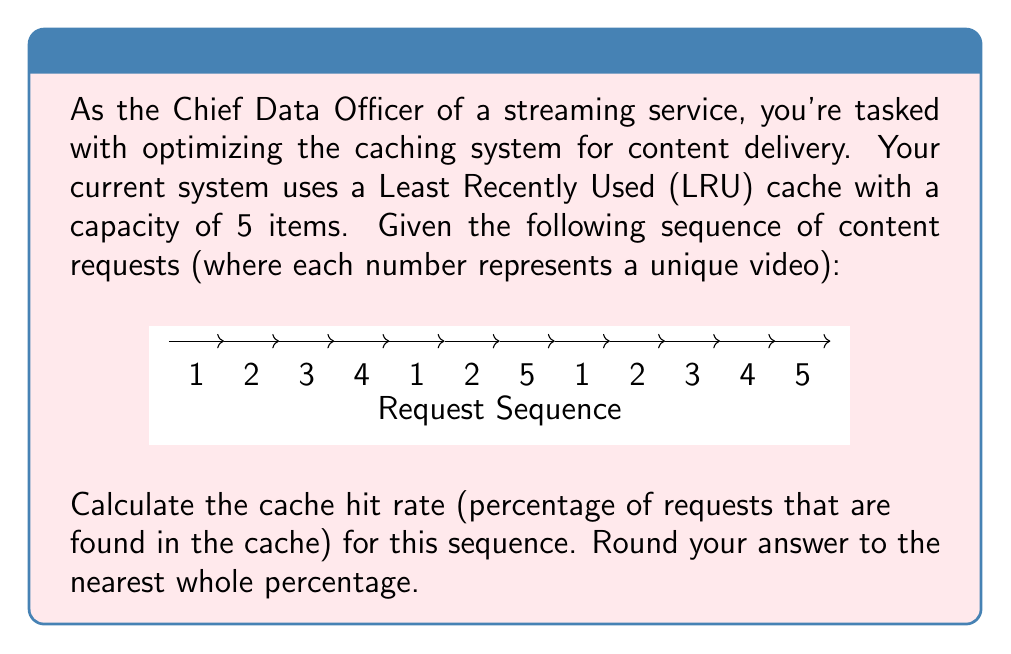Solve this math problem. Let's go through the sequence step-by-step, tracking the state of the LRU cache and counting hits:

1. [1] - Miss, cache: [1]
2. [2] - Miss, cache: [2, 1]
3. [3] - Miss, cache: [3, 2, 1]
4. [4] - Miss, cache: [4, 3, 2, 1]
5. [1] - Hit,  cache: [1, 4, 3, 2]
6. [2] - Hit,  cache: [2, 1, 4, 3]
7. [5] - Miss, cache: [5, 2, 1, 4, 3]
8. [1] - Hit,  cache: [1, 5, 2, 4, 3]
9. [2] - Hit,  cache: [2, 1, 5, 4, 3]
10. [3] - Miss, cache: [3, 2, 1, 5, 4]
11. [4] - Hit,  cache: [4, 3, 2, 1, 5]
12. [5] - Hit,  cache: [5, 4, 3, 2, 1]

Total requests: 12
Cache hits: 6

To calculate the cache hit rate:

$$\text{Cache Hit Rate} = \frac{\text{Number of Hits}}{\text{Total Requests}} \times 100\%$$

$$= \frac{6}{12} \times 100\% = 50\%$$

Therefore, the cache hit rate is 50%.
Answer: 50% 